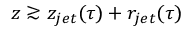<formula> <loc_0><loc_0><loc_500><loc_500>z \gtrsim z _ { j e t } ( \tau ) + r _ { j e t } ( \tau )</formula> 